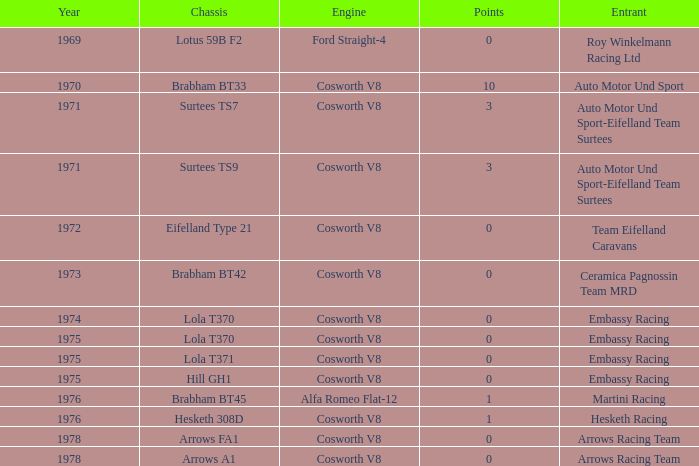What was the total amount of points in 1978 with a Chassis of arrows fa1? 0.0. 